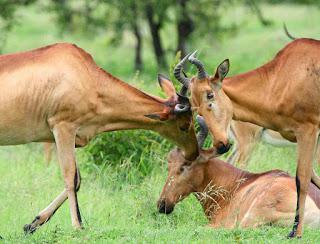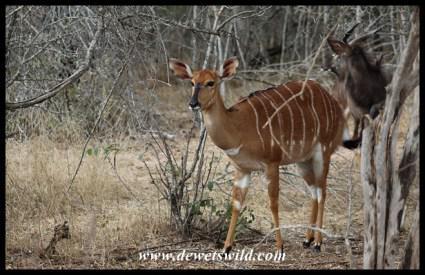The first image is the image on the left, the second image is the image on the right. Examine the images to the left and right. Is the description "All the animals have horns." accurate? Answer yes or no. No. The first image is the image on the left, the second image is the image on the right. Given the left and right images, does the statement "One image contains at least one hornless deer-like animal with vertical white stripes, and the other image features multiple animals with curved horns and at least one reclining animal." hold true? Answer yes or no. Yes. 